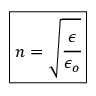Convert formula to latex. <formula><loc_0><loc_0><loc_500><loc_500>\boxed { n = \sqrt { \cfrac { \epsilon } { \epsilon _ { o } } } }</formula> 